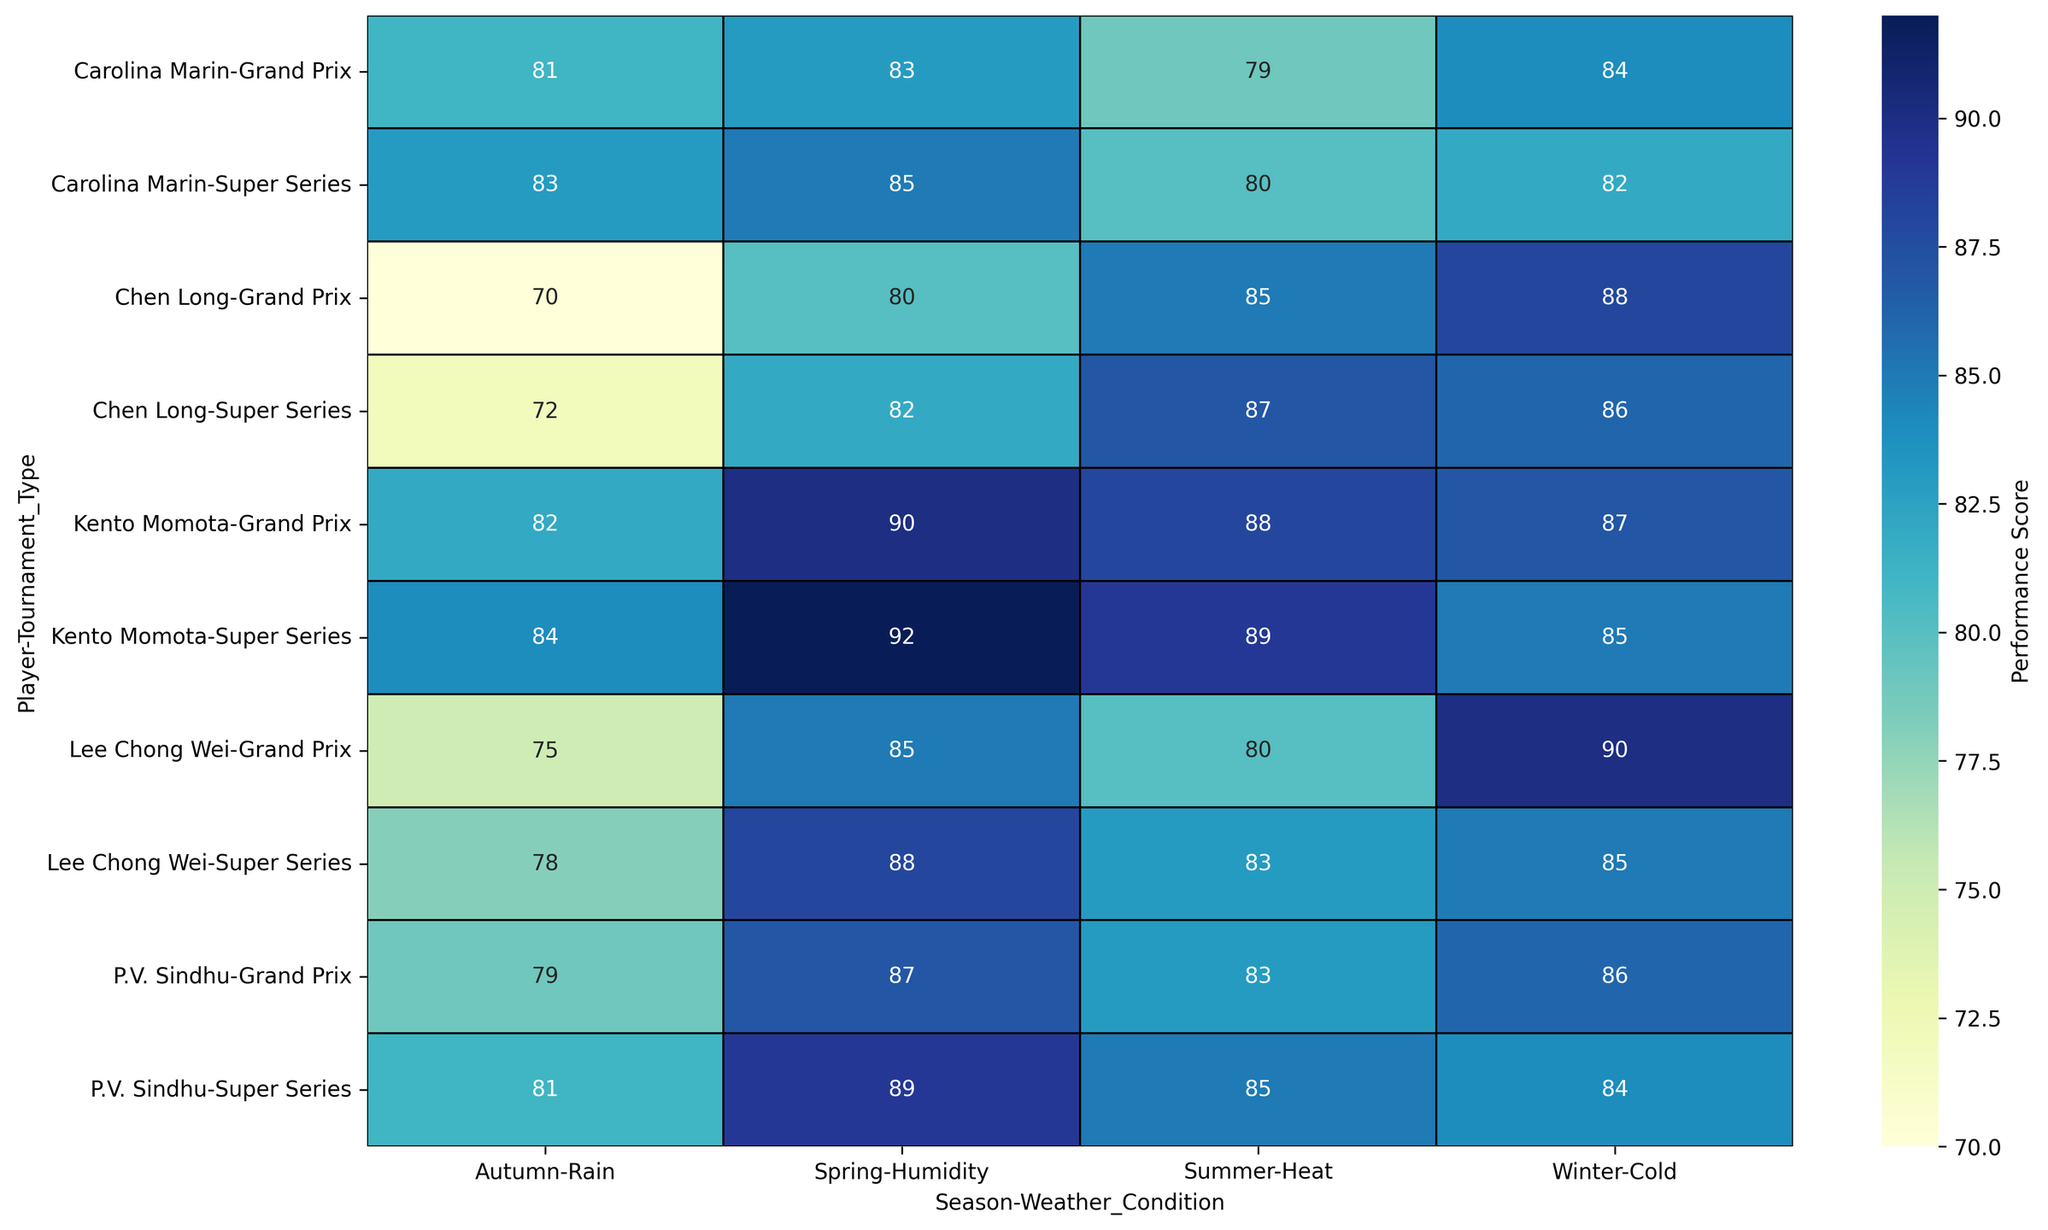Which player performed best in the Spring season for both tournament types and weather conditions? To find this, look at the heatmap values for each player's performance scores during Spring for the Grand Prix and Super Series under Humidity. Compare the scores and determine the highest.
Answer: Kento Momota Between Lee Chong Wei and Chen Long, who had higher overall performance scores in Winter? Identify the performance scores for both players in the Winter season for the Grand Prix and Super Series under Cold. Sum each player's scores for a comparison. Lee Chong Wei: 90 + 85, Chen Long: 88 + 86. Lee Chong Wei's total is 175, while Chen Long's is 174.
Answer: Lee Chong Wei What's the average performance score of Kento Momota across all seasons? Calculate Kento Momota's performance scores for all seasons by summing them up and dividing by the number of data points. Scores: 90, 92, 88, 89, 82, 84, 87, 85. Total: 697. Average: 697/8 = 87.125
Answer: 87.125 Who had the lowest performance score in the Autumn season and under which tournament type? Look at the performance scores for all players in the Autumn season for both Grand Prix and Super Series under Rain. The lowest score is 70 by Chen Long in the Grand Prix.
Answer: Chen Long, Grand Prix In which season did Carolina Marin perform better in the Super Series compared to the Grand Prix? Compare Carolina Marin's performance scores in the Super Series and Grand Prix for each season. Spring: 85 vs. 83, Summer: 80 vs. 79, Autumn: 83 vs. 81, Winter: 82 vs. 84. She performed better in the Super Series during Spring, Summer, and Autumn.
Answer: Spring, Summer, Autumn What is the performance score difference between Chen Long and P.V. Sindhu for the Super Series in Summer? Check Chen Long's and P.V. Sindhu's scores for the Summer Super Series. Chen Long: 87, P.V. Sindhu: 85. The difference is 87 - 85 = 2.
Answer: 2 How does Kento Momota's performance in the Grand Prix during Summer compare to his performance in the Super Series in the same season? Kento Momota's scores in Summer for Grand Prix: 88, Super Series: 89. He performed better by 1 point in the Super Series compared to the Grand Prix.
Answer: Super Series, +1 point Which player has the most consistent performance across all seasons in the Grand Prix? Calculate the standard deviation of performance scores for each player in the Grand Prix across all seasons to measure consistency. The player with the lowest standard deviation is the most consistent. Lee Chong Wei's scores: 85, 80, 75, 90. Standard deviation: ~5.91. Other players have larger variations.
Answer: Lee Chong Wei In which weather conditions does P.V. Sindhu perform the best overall? Check P.V. Sindhu's scores under different weather conditions across all tournaments and seasons. Humidity: 87, 89, Heat: 83, 85, Rain: 79, 81, Cold: 86, 84. The highest average is under Humidity.
Answer: Humidity What's the total performance score of all players in the Winter season for Super Series? Sum the Super Series performance scores for all players during the Winter season. Lee Chong Wei: 85, Chen Long: 86, Kento Momota: 85, Carolina Marin: 82, P.V. Sindhu: 84. Total: 85 + 86 + 85 + 82 + 84 = 422.
Answer: 422 